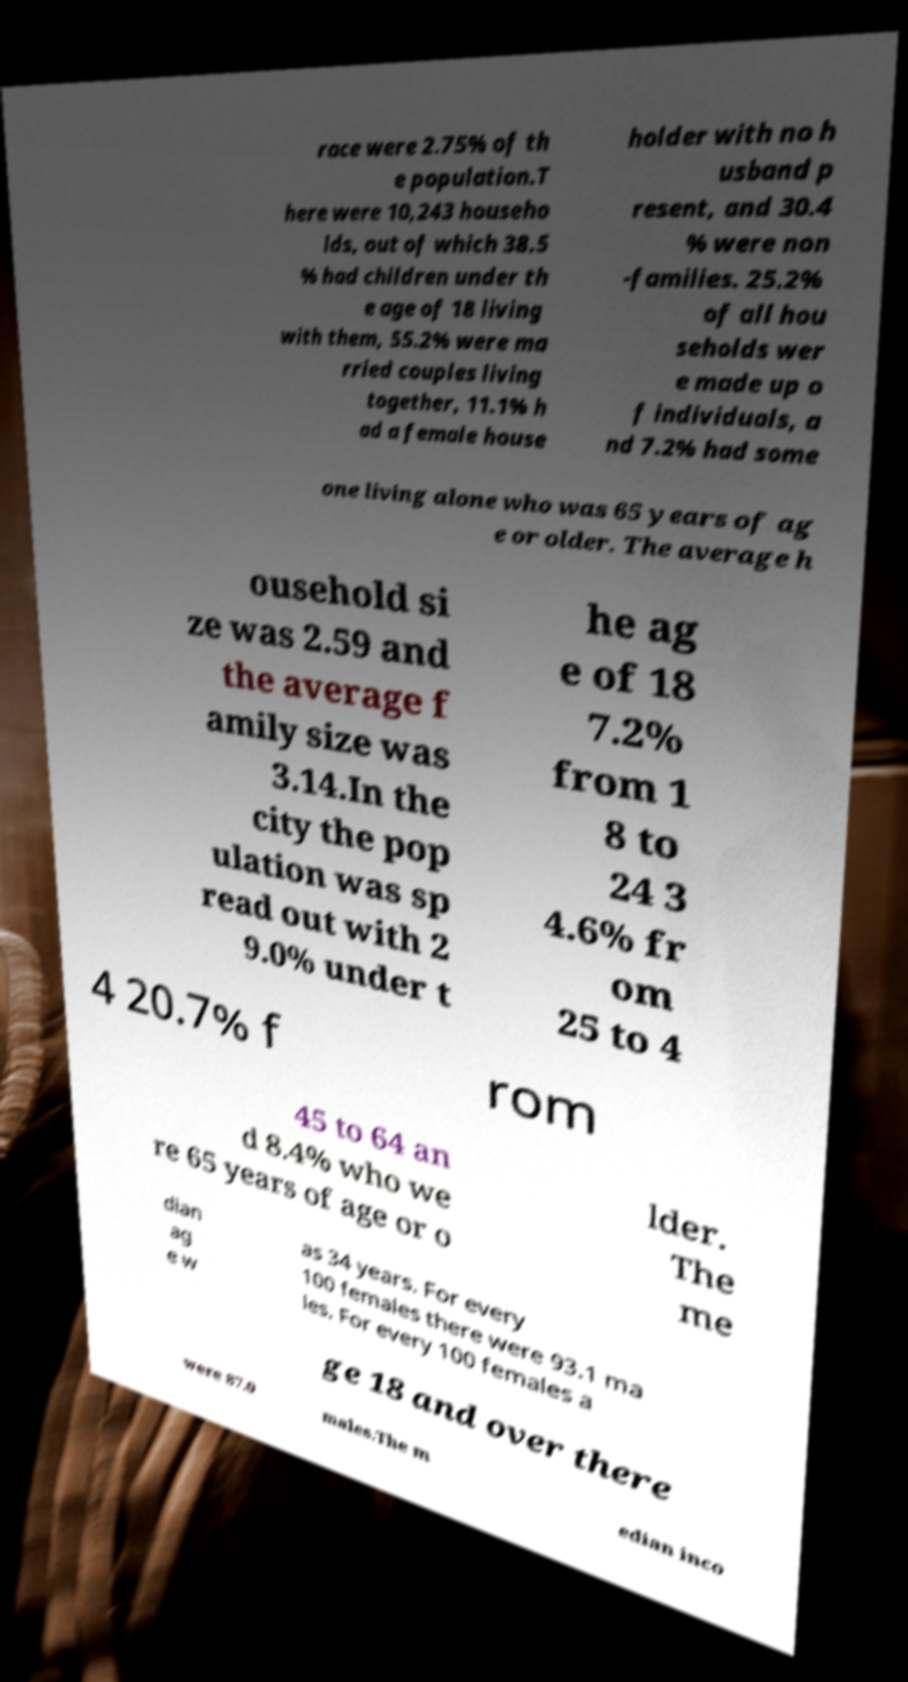Could you extract and type out the text from this image? race were 2.75% of th e population.T here were 10,243 househo lds, out of which 38.5 % had children under th e age of 18 living with them, 55.2% were ma rried couples living together, 11.1% h ad a female house holder with no h usband p resent, and 30.4 % were non -families. 25.2% of all hou seholds wer e made up o f individuals, a nd 7.2% had some one living alone who was 65 years of ag e or older. The average h ousehold si ze was 2.59 and the average f amily size was 3.14.In the city the pop ulation was sp read out with 2 9.0% under t he ag e of 18 7.2% from 1 8 to 24 3 4.6% fr om 25 to 4 4 20.7% f rom 45 to 64 an d 8.4% who we re 65 years of age or o lder. The me dian ag e w as 34 years. For every 100 females there were 93.1 ma les. For every 100 females a ge 18 and over there were 87.0 males.The m edian inco 